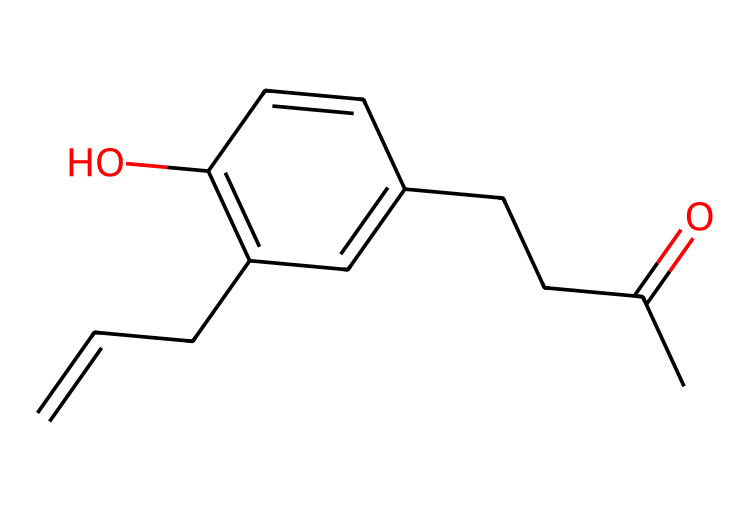What is the molecular formula of raspberry ketone? By analyzing the SMILES representation, we can count the number of atoms: the backbone and substituents include 10 carbons, 10 hydrogens, and 1 oxygen. Therefore, the molecular formula is deduced from this counting.
Answer: C10H10O How many double bonds are present in raspberry ketone? Observing the structural representation from the SMILES, we identify two double bonds: one in the ketone group (C=O) and one between two carbon atoms closer to the aromatic ring. Hence, we can conclude the total number of double bonds.
Answer: 2 What type of functional group is present in raspberry ketone? Identifying the structure, the presence of a carbonyl group (C=O) indicates that this molecule contains a ketone functional group. The presence of the oxygen in a carbonyl confirms the classification.
Answer: ketone What is the characteristic shape of raspberry ketone based on its structure? The structure reveals a mix of straight-chain and cyclic components. The aromatic ring suggests a planar structure while the aliphatic parts are involved in a three-dimensional arrangement. This is a typical characteristic of compounds with multiple groups.
Answer: planar How many chiral centers does raspberry ketone have? By examining the SMILES, chiral centers are identified at carbon atoms that are attached to four different groups. In this molecule, there are no carbon centers fitting this description, thus making it achiral.
Answer: 0 What does the hydroxyl group in raspberry ketone indicate? The hydroxyl (-OH) group denotes the presence of alcohol characteristics in the compound. In the structure of raspberry ketone, it shows additional reactivity and intermolecular interactions, which play a role in its biological activity.
Answer: alcohol 